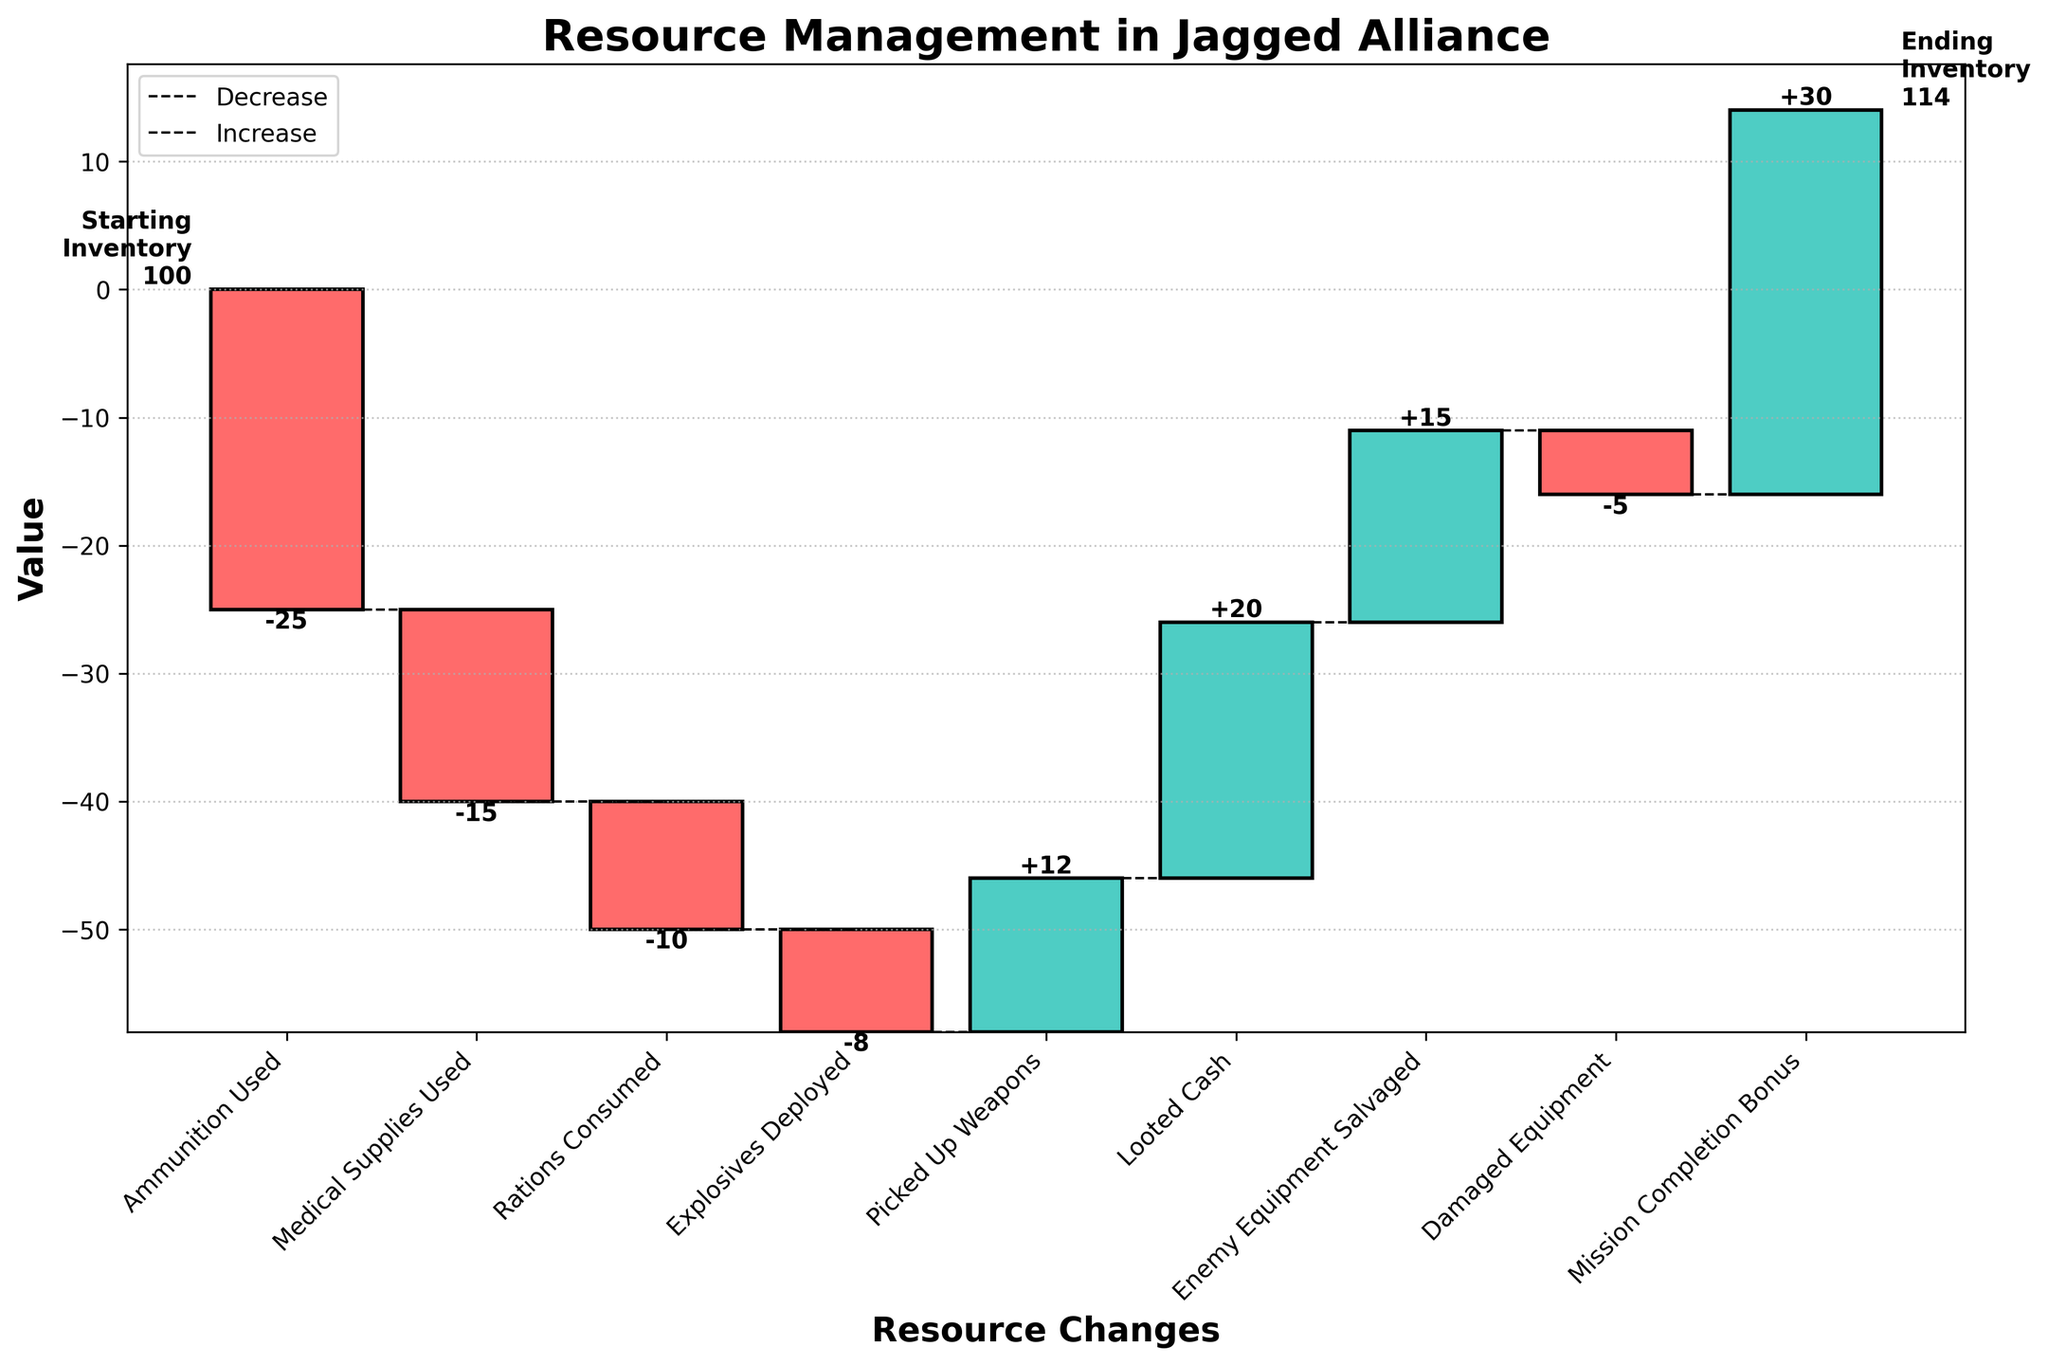What's the title of the chart? The title of the chart is displayed at the top and gives an overview of the chart's subject, which is resource management in Jagged Alliance.
Answer: Resource Management in Jagged Alliance What is the value for the category "Rations Consumed"? To find the value, locate the bar labeled "Rations Consumed" and read its value from the plot, which is also annotated near the bar.
Answer: -10 What is the cumulative value after "Picked Up Weapons"? You need to sum the starting inventory (100) with all changes up to and including "Picked Up Weapons": 100 - 25 - 15 - 10 - 8 + 12. The cumulative value after these changes is 54.
Answer: 54 How many categories show a decrease in inventory? Identify the bars representing negative values, which are colored differently (e.g., red). Count these bars: 'Ammunition Used', 'Medical Supplies Used', 'Rations Consumed', 'Explosives Deployed', 'Damaged Equipment'. There are 5 categories.
Answer: 5 Which category contributed the most to the increase in inventory? Compare the bars representing positive values (e.g., colored green) and identify the largest one, which corresponds to the category with the greatest positive value. "Mission Completion Bonus" has the largest positive value of +30.
Answer: Mission Completion Bonus What is the total increase in inventory from positive changes? Sum all the positive contributions: +12 (Picked Up Weapons) + 20 (Looted Cash) + 15 (Enemy Equipment Salvaged) + 30 (Mission Completion Bonus). The total increase is: 12 + 20 + 15 + 30 = 77.
Answer: 77 What is the net change in inventory by the end of the mission? Calculate the net change by considering the difference between the ending and starting inventory: Ending Inventory (114) - Starting Inventory (100). The net change is +14.
Answer: 14 Which category had the smallest impact on inventory change, considering both increases and decreases? Compare the absolute values of all categories' changes and identify the smallest one. "Explosives Deployed" with a change of -8 has the smallest absolute impact.
Answer: Explosives Deployed What is the final inventory after accounting for all changes? According to the plot, the final inventory value after summing all changes should match the ending inventory displayed on the plot. The ending inventory is 114.
Answer: 114 How does the value for "Looted Cash" compare to "Enemy Equipment Salvaged"? Check both categories' values: "Looted Cash" is +20 and "Enemy Equipment Salvaged" is +15. Then compare +20 to +15. "Looted Cash" is higher.
Answer: Looted Cash is higher 